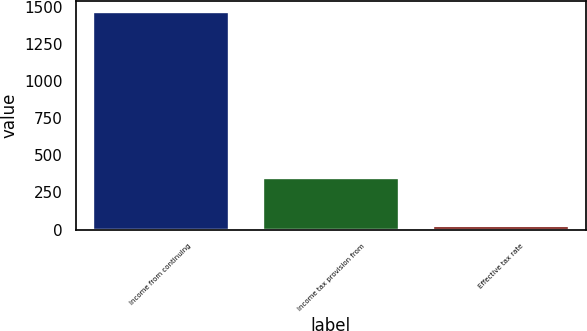Convert chart. <chart><loc_0><loc_0><loc_500><loc_500><bar_chart><fcel>Income from continuing<fcel>Income tax provision from<fcel>Effective tax rate<nl><fcel>1471<fcel>350<fcel>21.5<nl></chart> 